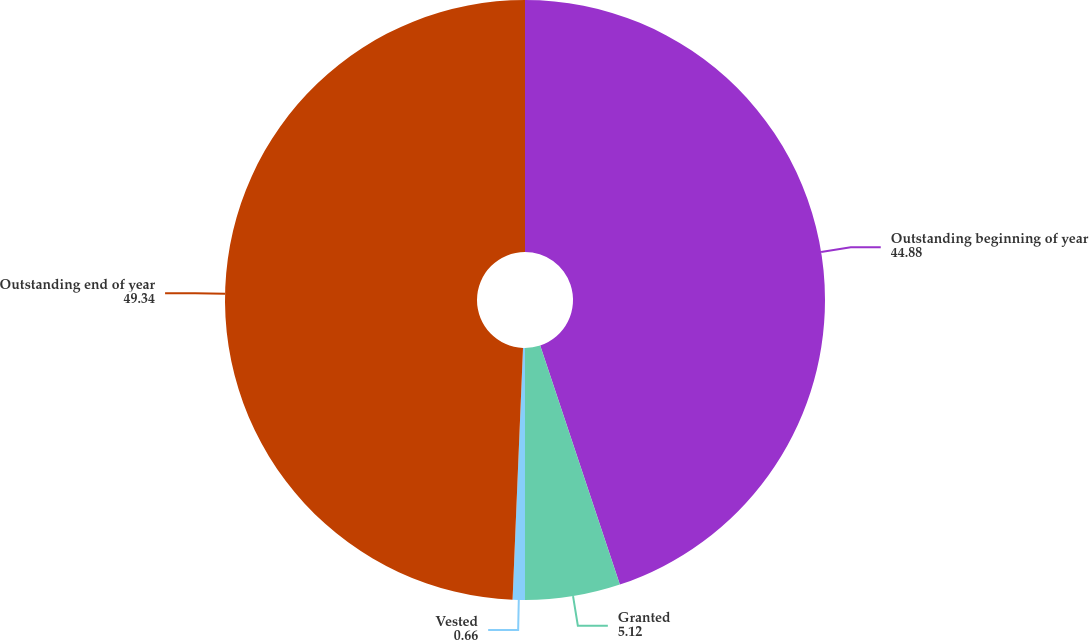Convert chart to OTSL. <chart><loc_0><loc_0><loc_500><loc_500><pie_chart><fcel>Outstanding beginning of year<fcel>Granted<fcel>Vested<fcel>Outstanding end of year<nl><fcel>44.88%<fcel>5.12%<fcel>0.66%<fcel>49.34%<nl></chart> 